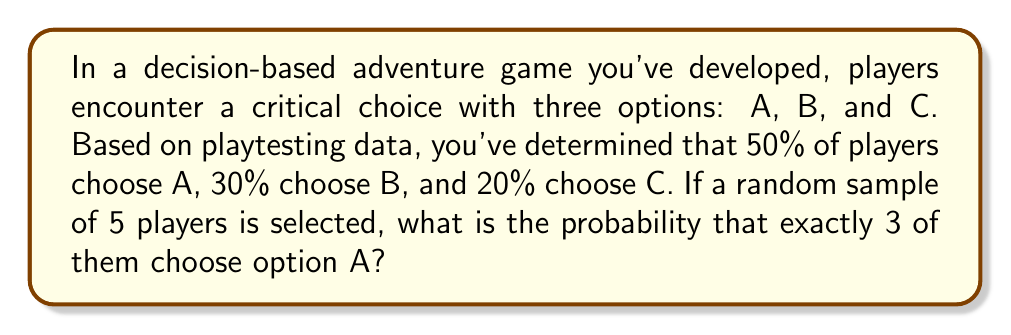Teach me how to tackle this problem. To solve this problem, we need to use the binomial probability distribution, as we're dealing with a fixed number of independent trials (5 players) with a constant probability of success (choosing option A) for each trial.

The binomial probability formula is:

$$P(X = k) = \binom{n}{k} p^k (1-p)^{n-k}$$

Where:
$n$ = number of trials (5 players)
$k$ = number of successes (3 players choosing A)
$p$ = probability of success on each trial (0.50 for option A)

Let's plug in the values:

$$P(X = 3) = \binom{5}{3} (0.50)^3 (1-0.50)^{5-3}$$

1. Calculate the binomial coefficient:
   $$\binom{5}{3} = \frac{5!}{3!(5-3)!} = \frac{5!}{3!2!} = 10$$

2. Compute the probability:
   $$P(X = 3) = 10 \cdot (0.50)^3 \cdot (0.50)^2$$
   $$= 10 \cdot 0.125 \cdot 0.25$$
   $$= 10 \cdot 0.03125$$
   $$= 0.3125$$

Therefore, the probability that exactly 3 out of 5 randomly selected players choose option A is 0.3125 or 31.25%.
Answer: 0.3125 or 31.25% 